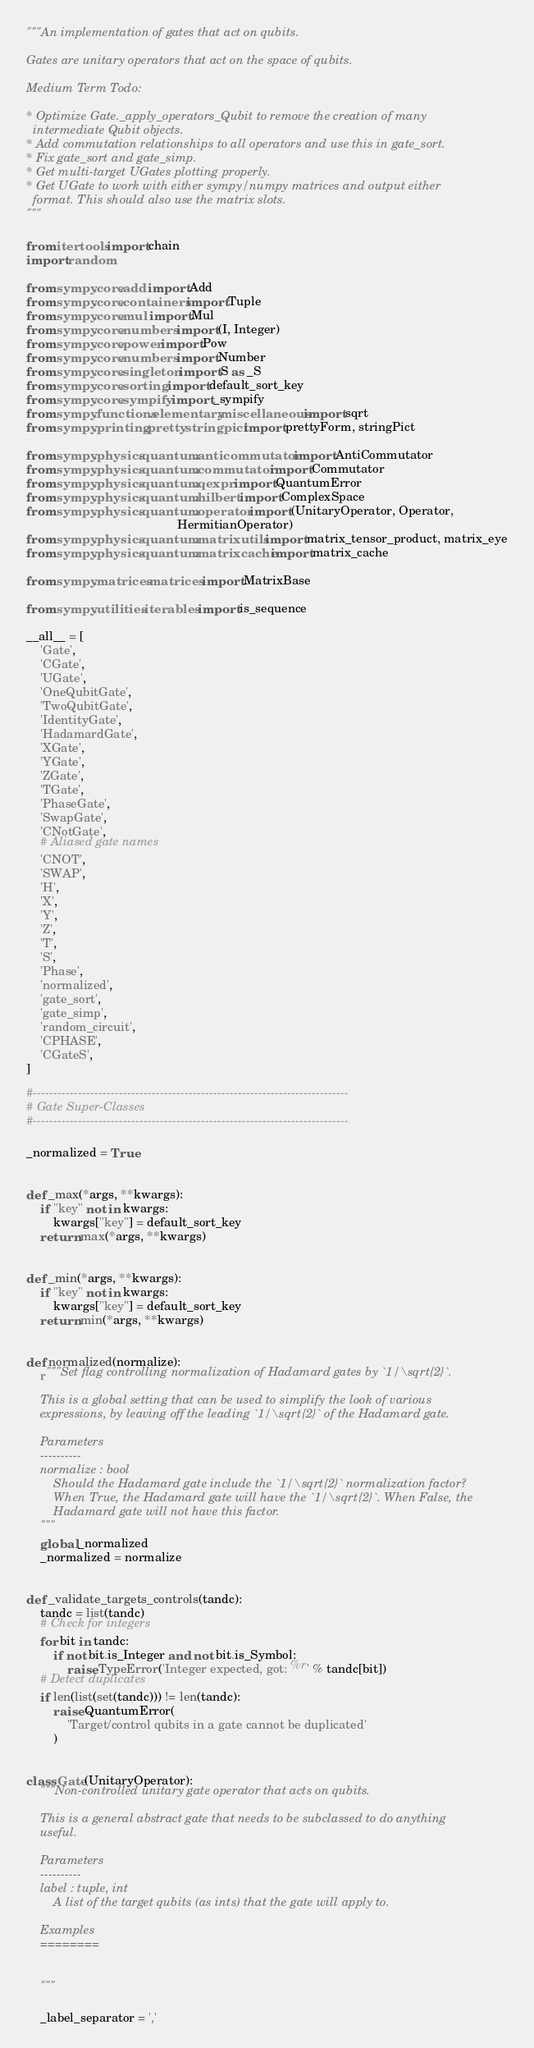<code> <loc_0><loc_0><loc_500><loc_500><_Python_>"""An implementation of gates that act on qubits.

Gates are unitary operators that act on the space of qubits.

Medium Term Todo:

* Optimize Gate._apply_operators_Qubit to remove the creation of many
  intermediate Qubit objects.
* Add commutation relationships to all operators and use this in gate_sort.
* Fix gate_sort and gate_simp.
* Get multi-target UGates plotting properly.
* Get UGate to work with either sympy/numpy matrices and output either
  format. This should also use the matrix slots.
"""

from itertools import chain
import random

from sympy.core.add import Add
from sympy.core.containers import Tuple
from sympy.core.mul import Mul
from sympy.core.numbers import (I, Integer)
from sympy.core.power import Pow
from sympy.core.numbers import Number
from sympy.core.singleton import S as _S
from sympy.core.sorting import default_sort_key
from sympy.core.sympify import _sympify
from sympy.functions.elementary.miscellaneous import sqrt
from sympy.printing.pretty.stringpict import prettyForm, stringPict

from sympy.physics.quantum.anticommutator import AntiCommutator
from sympy.physics.quantum.commutator import Commutator
from sympy.physics.quantum.qexpr import QuantumError
from sympy.physics.quantum.hilbert import ComplexSpace
from sympy.physics.quantum.operator import (UnitaryOperator, Operator,
                                            HermitianOperator)
from sympy.physics.quantum.matrixutils import matrix_tensor_product, matrix_eye
from sympy.physics.quantum.matrixcache import matrix_cache

from sympy.matrices.matrices import MatrixBase

from sympy.utilities.iterables import is_sequence

__all__ = [
    'Gate',
    'CGate',
    'UGate',
    'OneQubitGate',
    'TwoQubitGate',
    'IdentityGate',
    'HadamardGate',
    'XGate',
    'YGate',
    'ZGate',
    'TGate',
    'PhaseGate',
    'SwapGate',
    'CNotGate',
    # Aliased gate names
    'CNOT',
    'SWAP',
    'H',
    'X',
    'Y',
    'Z',
    'T',
    'S',
    'Phase',
    'normalized',
    'gate_sort',
    'gate_simp',
    'random_circuit',
    'CPHASE',
    'CGateS',
]

#-----------------------------------------------------------------------------
# Gate Super-Classes
#-----------------------------------------------------------------------------

_normalized = True


def _max(*args, **kwargs):
    if "key" not in kwargs:
        kwargs["key"] = default_sort_key
    return max(*args, **kwargs)


def _min(*args, **kwargs):
    if "key" not in kwargs:
        kwargs["key"] = default_sort_key
    return min(*args, **kwargs)


def normalized(normalize):
    r"""Set flag controlling normalization of Hadamard gates by `1/\sqrt{2}`.

    This is a global setting that can be used to simplify the look of various
    expressions, by leaving off the leading `1/\sqrt{2}` of the Hadamard gate.

    Parameters
    ----------
    normalize : bool
        Should the Hadamard gate include the `1/\sqrt{2}` normalization factor?
        When True, the Hadamard gate will have the `1/\sqrt{2}`. When False, the
        Hadamard gate will not have this factor.
    """
    global _normalized
    _normalized = normalize


def _validate_targets_controls(tandc):
    tandc = list(tandc)
    # Check for integers
    for bit in tandc:
        if not bit.is_Integer and not bit.is_Symbol:
            raise TypeError('Integer expected, got: %r' % tandc[bit])
    # Detect duplicates
    if len(list(set(tandc))) != len(tandc):
        raise QuantumError(
            'Target/control qubits in a gate cannot be duplicated'
        )


class Gate(UnitaryOperator):
    """Non-controlled unitary gate operator that acts on qubits.

    This is a general abstract gate that needs to be subclassed to do anything
    useful.

    Parameters
    ----------
    label : tuple, int
        A list of the target qubits (as ints) that the gate will apply to.

    Examples
    ========


    """

    _label_separator = ','</code> 